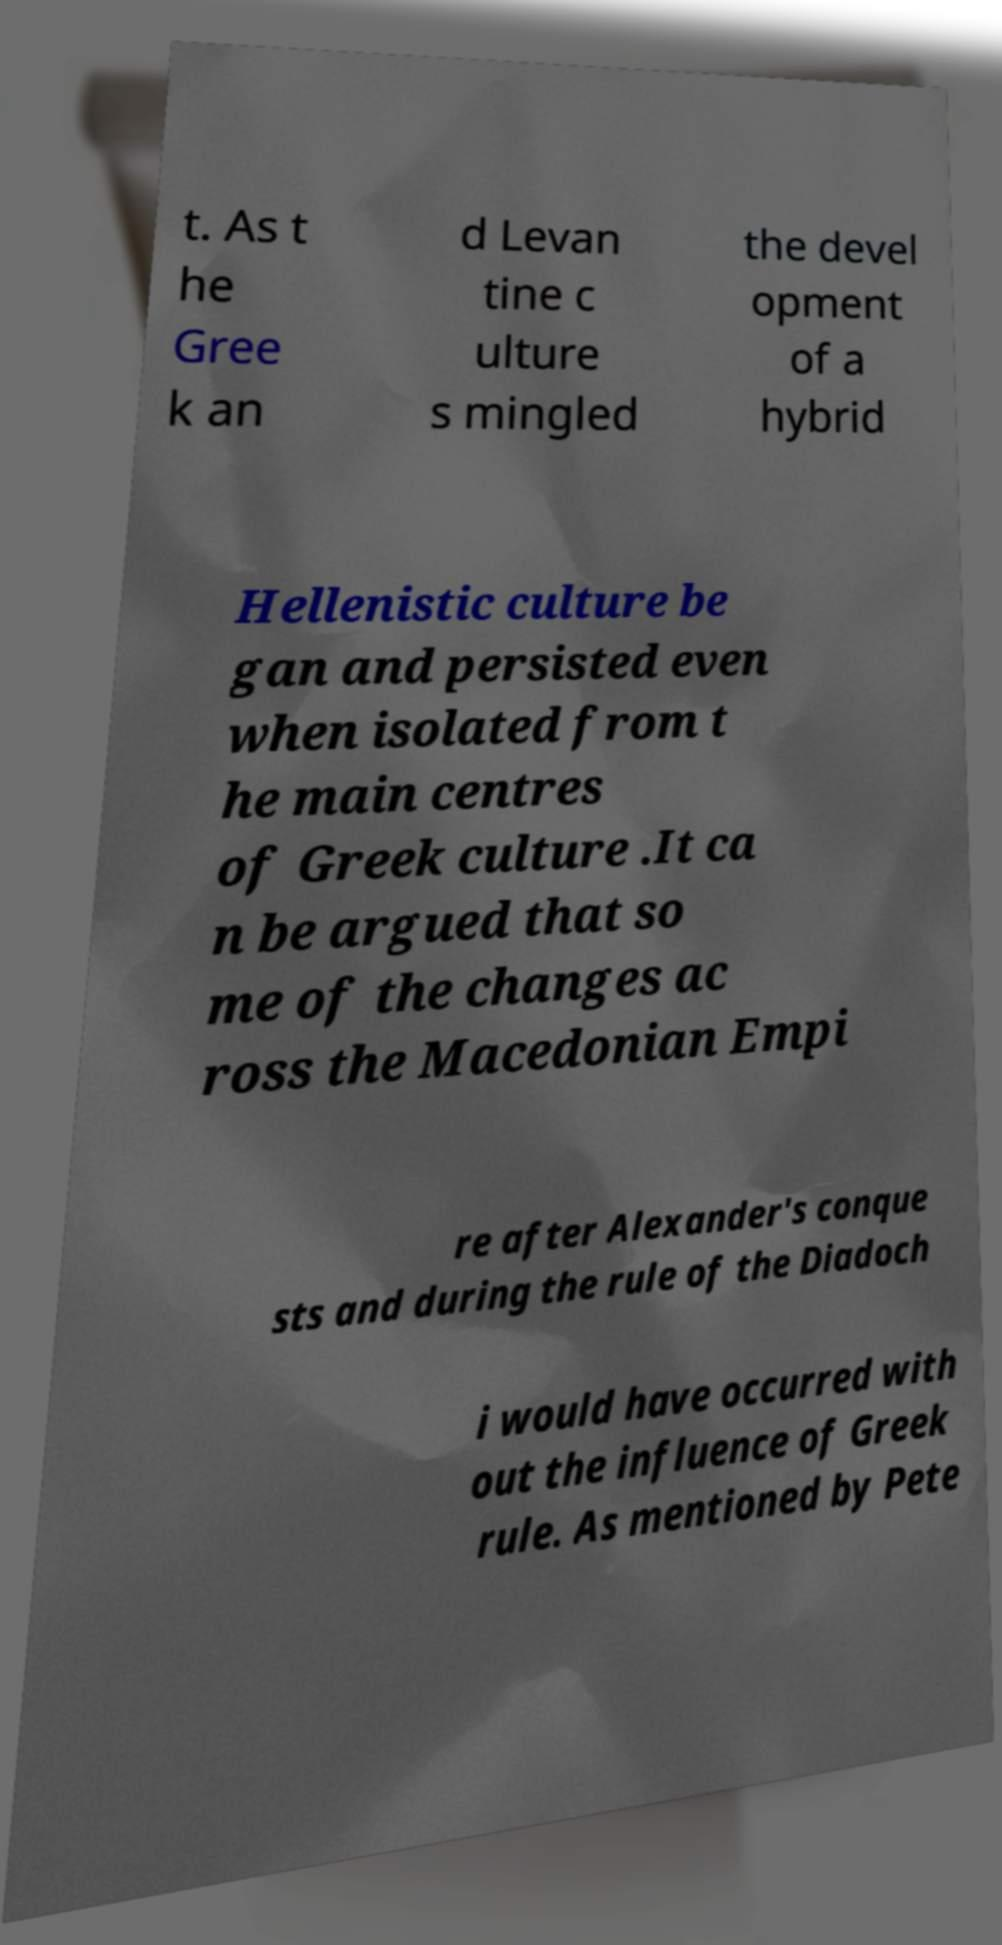Please identify and transcribe the text found in this image. t. As t he Gree k an d Levan tine c ulture s mingled the devel opment of a hybrid Hellenistic culture be gan and persisted even when isolated from t he main centres of Greek culture .It ca n be argued that so me of the changes ac ross the Macedonian Empi re after Alexander's conque sts and during the rule of the Diadoch i would have occurred with out the influence of Greek rule. As mentioned by Pete 